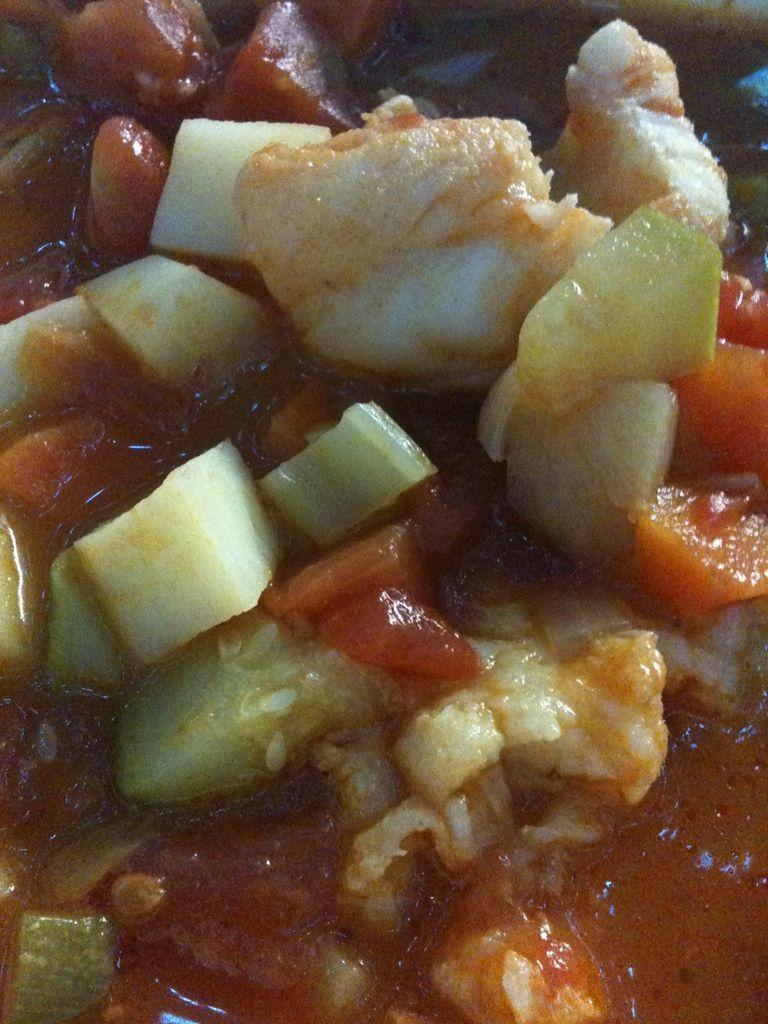What types of items can be seen in the image? There are food items and vegetables in the image. Can you describe the food items in more detail? Unfortunately, the facts provided do not specify the types of food items in the image. What types of vegetables are present in the image? The facts provided do not specify the types of vegetables in the image. What type of glass is being used to read a fictional railway story in the image? There is no glass, fictional railway story, or reading activity depicted in the image. 